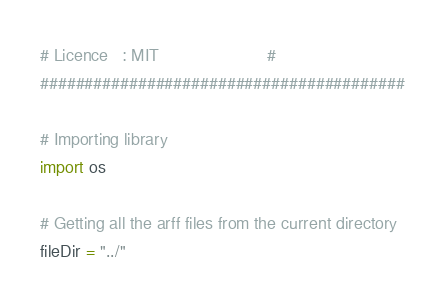<code> <loc_0><loc_0><loc_500><loc_500><_Python_># Licence   : MIT                       #
#########################################

# Importing library
import os

# Getting all the arff files from the current directory
fileDir = "../"</code> 